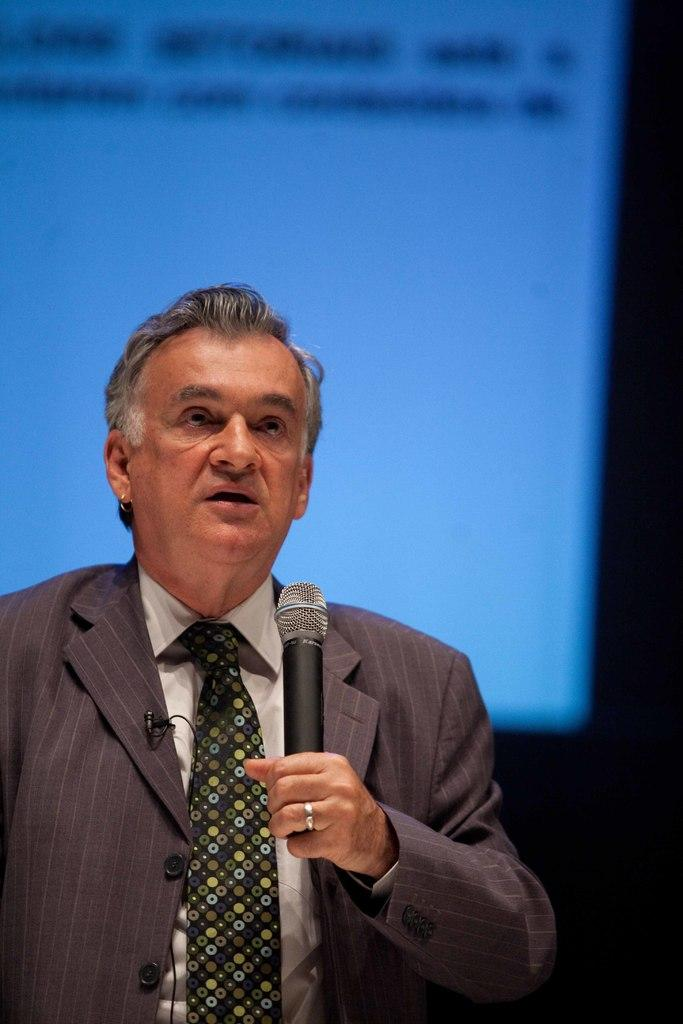What is in the background of the image? There is a screen in the background of the image. Who is present in the image? There is a man in the image. What is the man holding in his hand? The man is holding a microphone in his hand. What is the man doing in the image? The man is talking. Can you describe any accessories the man is wearing? The man has a ring on his finger. What type of cap is the man wearing in the image? There is no cap visible in the image; the man is not wearing one. What is the man doing with his mouth in the image? The man is talking, but we cannot see his mouth in the image. 